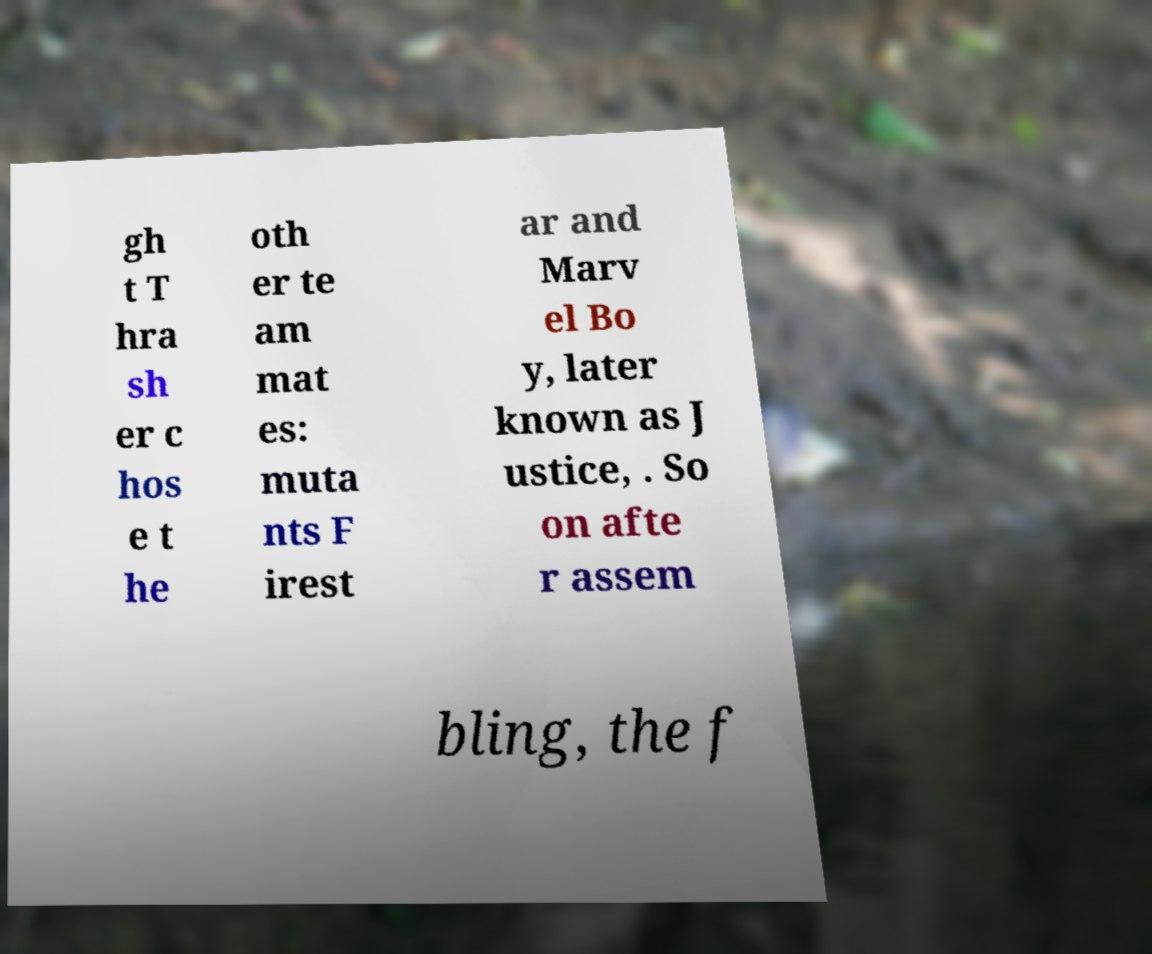Could you assist in decoding the text presented in this image and type it out clearly? gh t T hra sh er c hos e t he oth er te am mat es: muta nts F irest ar and Marv el Bo y, later known as J ustice, . So on afte r assem bling, the f 